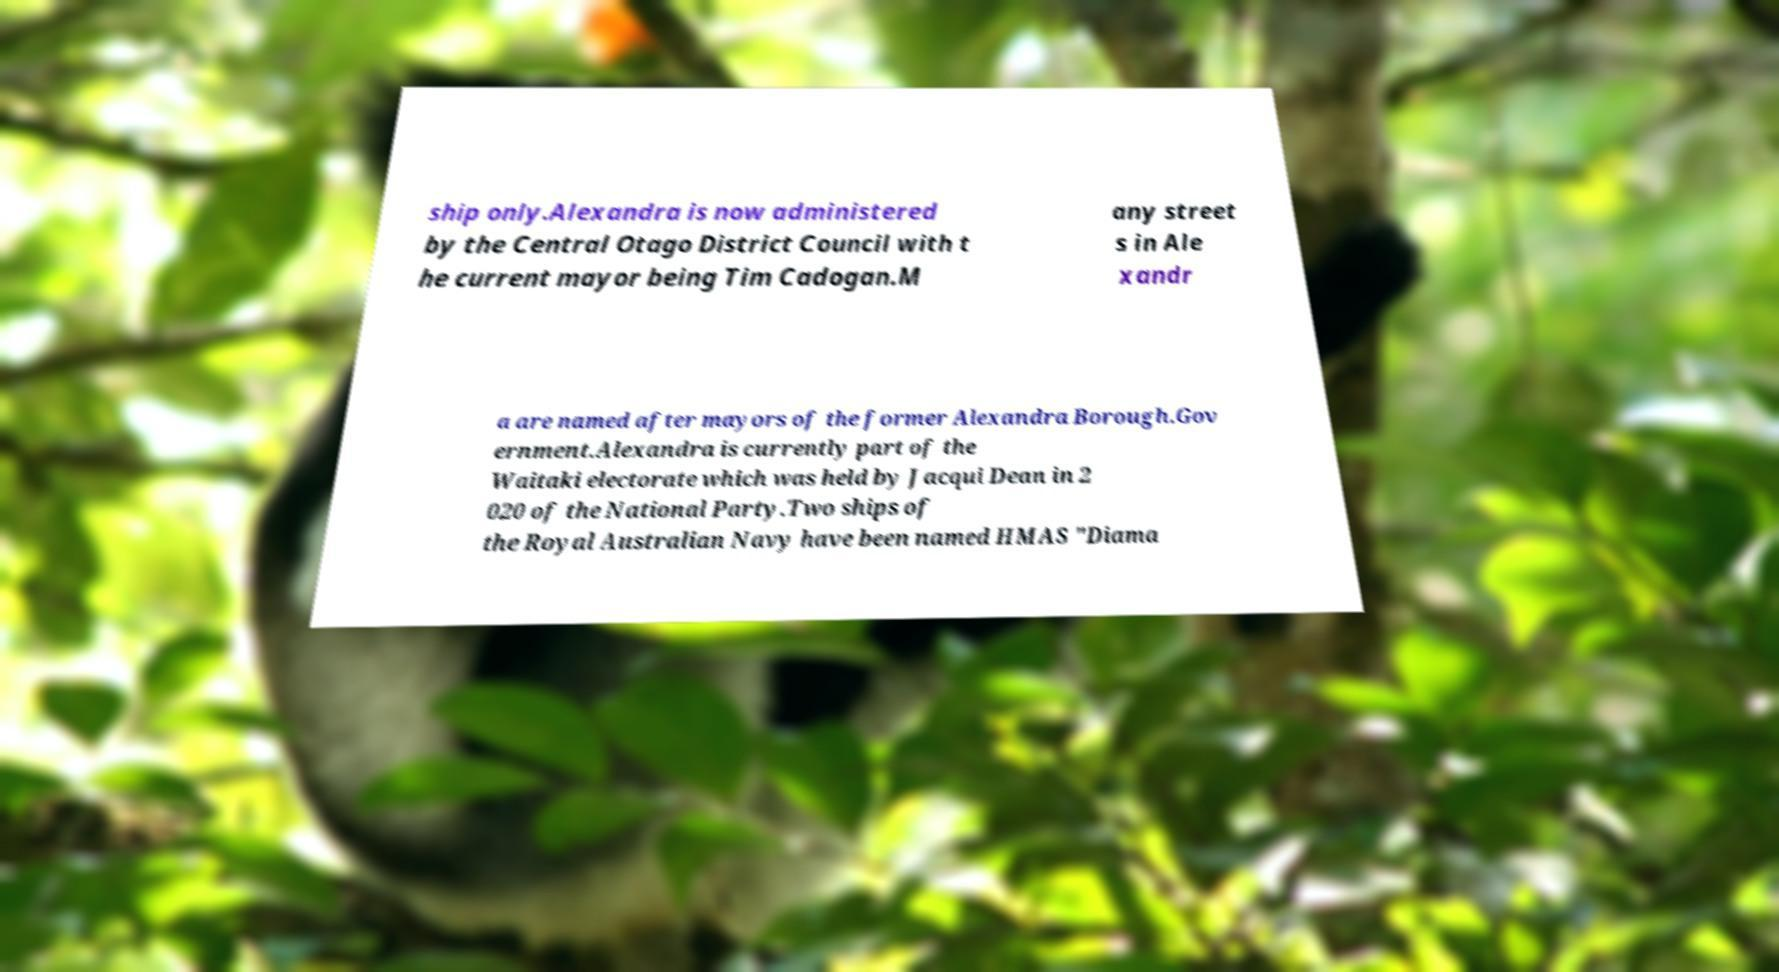There's text embedded in this image that I need extracted. Can you transcribe it verbatim? ship only.Alexandra is now administered by the Central Otago District Council with t he current mayor being Tim Cadogan.M any street s in Ale xandr a are named after mayors of the former Alexandra Borough.Gov ernment.Alexandra is currently part of the Waitaki electorate which was held by Jacqui Dean in 2 020 of the National Party.Two ships of the Royal Australian Navy have been named HMAS "Diama 